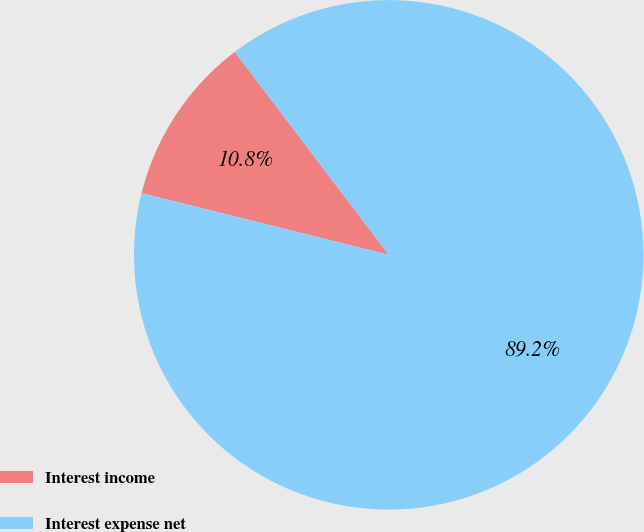<chart> <loc_0><loc_0><loc_500><loc_500><pie_chart><fcel>Interest income<fcel>Interest expense net<nl><fcel>10.78%<fcel>89.22%<nl></chart> 